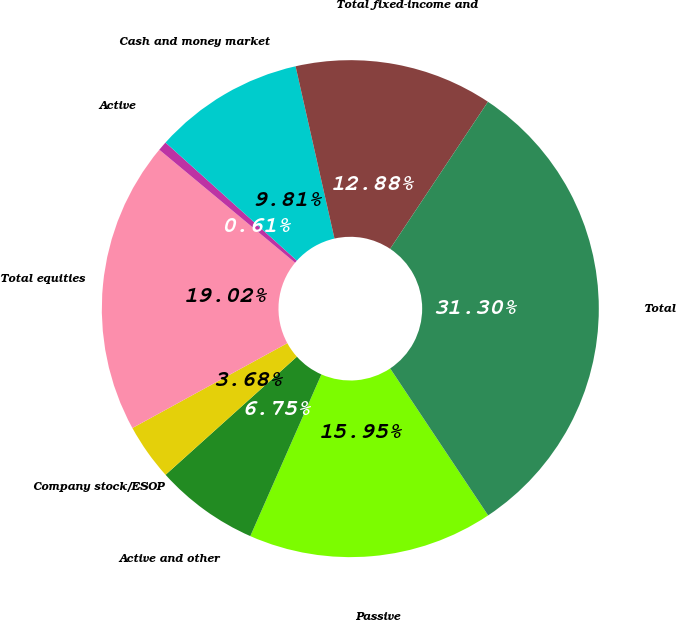Convert chart. <chart><loc_0><loc_0><loc_500><loc_500><pie_chart><fcel>Passive<fcel>Active and other<fcel>Company stock/ESOP<fcel>Total equities<fcel>Active<fcel>Cash and money market<fcel>Total fixed-income and<fcel>Total<nl><fcel>15.95%<fcel>6.75%<fcel>3.68%<fcel>19.02%<fcel>0.61%<fcel>9.81%<fcel>12.88%<fcel>31.3%<nl></chart> 